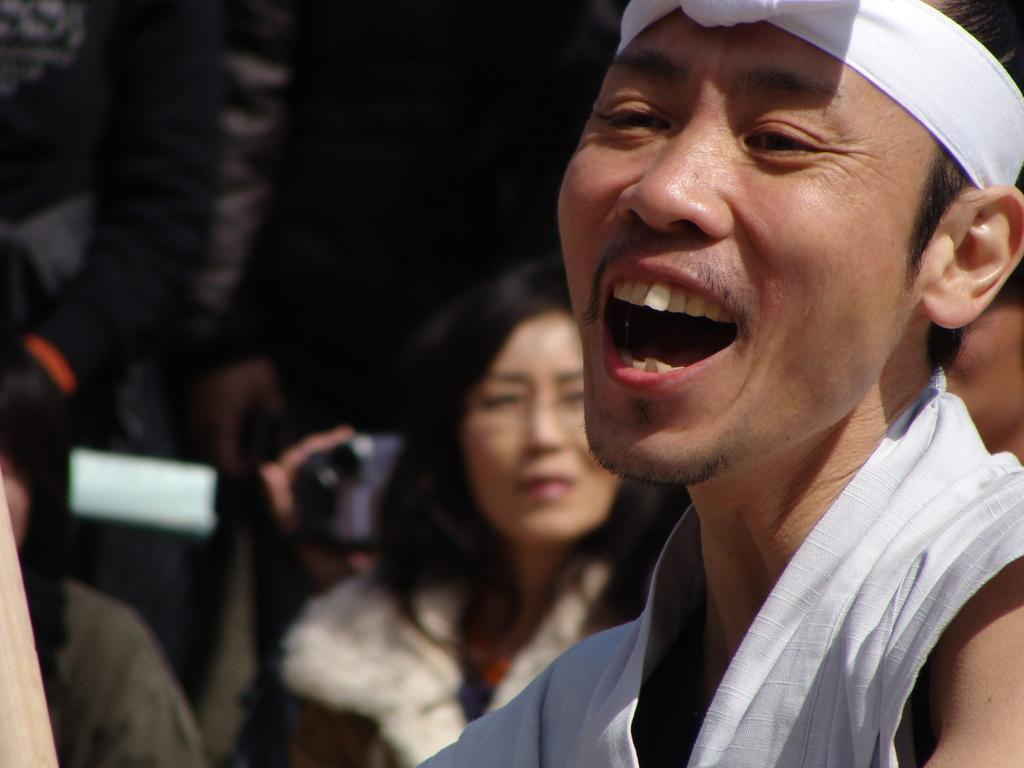Who or what is the main subject of the image? There is a person in the image. Can you describe the surroundings of the person? There are people and objects in the background of the image. What type of sack is being used by the person in the image? There is no sack visible in the image. What part of the stage is the person standing on in the image? There is no stage present in the image; it is not an image of a performance or theatrical setting. 